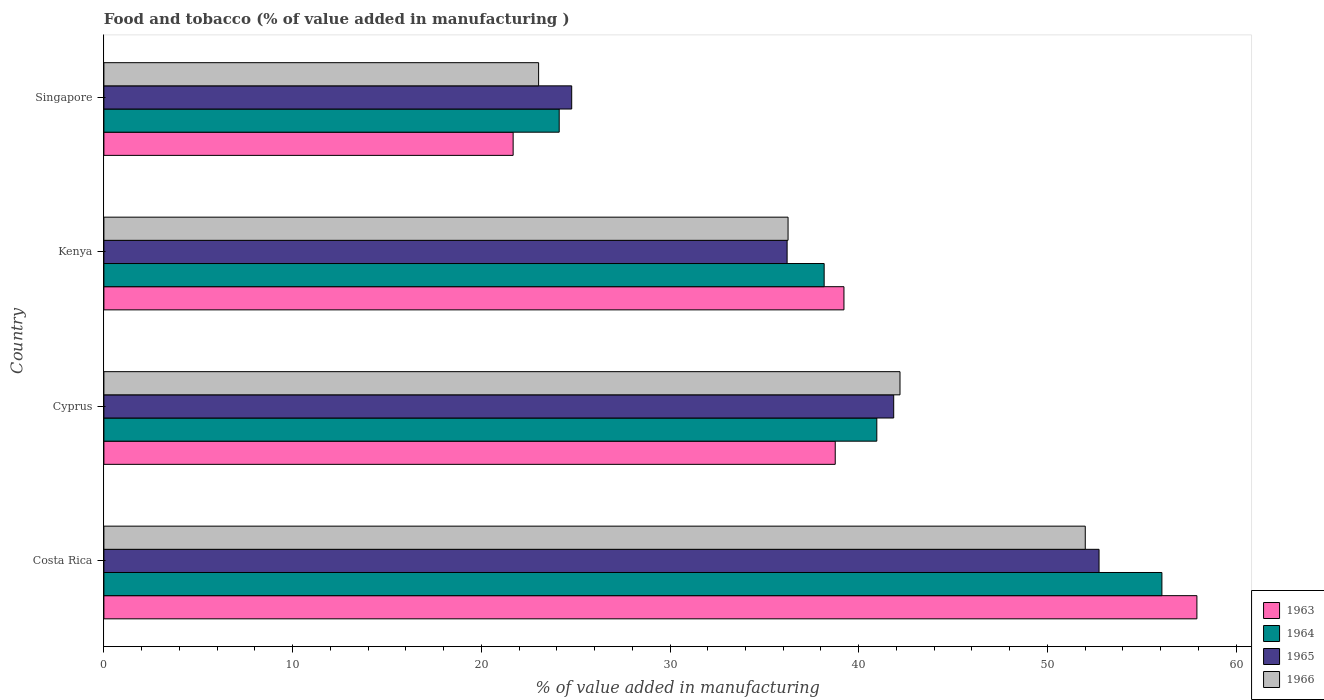How many different coloured bars are there?
Your answer should be compact. 4. How many groups of bars are there?
Provide a short and direct response. 4. How many bars are there on the 3rd tick from the bottom?
Offer a very short reply. 4. What is the label of the 1st group of bars from the top?
Keep it short and to the point. Singapore. In how many cases, is the number of bars for a given country not equal to the number of legend labels?
Offer a terse response. 0. What is the value added in manufacturing food and tobacco in 1966 in Cyprus?
Keep it short and to the point. 42.19. Across all countries, what is the maximum value added in manufacturing food and tobacco in 1965?
Keep it short and to the point. 52.73. Across all countries, what is the minimum value added in manufacturing food and tobacco in 1965?
Keep it short and to the point. 24.79. In which country was the value added in manufacturing food and tobacco in 1963 maximum?
Your response must be concise. Costa Rica. In which country was the value added in manufacturing food and tobacco in 1966 minimum?
Your answer should be very brief. Singapore. What is the total value added in manufacturing food and tobacco in 1965 in the graph?
Provide a short and direct response. 155.58. What is the difference between the value added in manufacturing food and tobacco in 1965 in Kenya and that in Singapore?
Keep it short and to the point. 11.41. What is the difference between the value added in manufacturing food and tobacco in 1964 in Costa Rica and the value added in manufacturing food and tobacco in 1966 in Singapore?
Offer a terse response. 33.03. What is the average value added in manufacturing food and tobacco in 1964 per country?
Your response must be concise. 39.83. What is the difference between the value added in manufacturing food and tobacco in 1966 and value added in manufacturing food and tobacco in 1965 in Costa Rica?
Keep it short and to the point. -0.73. What is the ratio of the value added in manufacturing food and tobacco in 1963 in Cyprus to that in Kenya?
Offer a terse response. 0.99. What is the difference between the highest and the second highest value added in manufacturing food and tobacco in 1965?
Provide a succinct answer. 10.88. What is the difference between the highest and the lowest value added in manufacturing food and tobacco in 1966?
Your answer should be compact. 28.97. In how many countries, is the value added in manufacturing food and tobacco in 1964 greater than the average value added in manufacturing food and tobacco in 1964 taken over all countries?
Offer a terse response. 2. What does the 1st bar from the top in Cyprus represents?
Ensure brevity in your answer.  1966. What does the 4th bar from the bottom in Kenya represents?
Provide a succinct answer. 1966. Is it the case that in every country, the sum of the value added in manufacturing food and tobacco in 1963 and value added in manufacturing food and tobacco in 1966 is greater than the value added in manufacturing food and tobacco in 1964?
Your answer should be very brief. Yes. How many countries are there in the graph?
Ensure brevity in your answer.  4. Are the values on the major ticks of X-axis written in scientific E-notation?
Make the answer very short. No. Does the graph contain any zero values?
Offer a very short reply. No. Does the graph contain grids?
Offer a very short reply. No. How many legend labels are there?
Provide a succinct answer. 4. How are the legend labels stacked?
Your response must be concise. Vertical. What is the title of the graph?
Make the answer very short. Food and tobacco (% of value added in manufacturing ). Does "2001" appear as one of the legend labels in the graph?
Provide a succinct answer. No. What is the label or title of the X-axis?
Ensure brevity in your answer.  % of value added in manufacturing. What is the label or title of the Y-axis?
Make the answer very short. Country. What is the % of value added in manufacturing in 1963 in Costa Rica?
Your answer should be compact. 57.92. What is the % of value added in manufacturing of 1964 in Costa Rica?
Keep it short and to the point. 56.07. What is the % of value added in manufacturing in 1965 in Costa Rica?
Give a very brief answer. 52.73. What is the % of value added in manufacturing of 1966 in Costa Rica?
Keep it short and to the point. 52. What is the % of value added in manufacturing in 1963 in Cyprus?
Make the answer very short. 38.75. What is the % of value added in manufacturing of 1964 in Cyprus?
Keep it short and to the point. 40.96. What is the % of value added in manufacturing in 1965 in Cyprus?
Your response must be concise. 41.85. What is the % of value added in manufacturing in 1966 in Cyprus?
Give a very brief answer. 42.19. What is the % of value added in manufacturing of 1963 in Kenya?
Offer a terse response. 39.22. What is the % of value added in manufacturing in 1964 in Kenya?
Provide a succinct answer. 38.17. What is the % of value added in manufacturing in 1965 in Kenya?
Keep it short and to the point. 36.2. What is the % of value added in manufacturing in 1966 in Kenya?
Your response must be concise. 36.25. What is the % of value added in manufacturing of 1963 in Singapore?
Ensure brevity in your answer.  21.69. What is the % of value added in manufacturing in 1964 in Singapore?
Offer a very short reply. 24.13. What is the % of value added in manufacturing in 1965 in Singapore?
Provide a short and direct response. 24.79. What is the % of value added in manufacturing in 1966 in Singapore?
Offer a terse response. 23.04. Across all countries, what is the maximum % of value added in manufacturing of 1963?
Keep it short and to the point. 57.92. Across all countries, what is the maximum % of value added in manufacturing of 1964?
Keep it short and to the point. 56.07. Across all countries, what is the maximum % of value added in manufacturing in 1965?
Provide a succinct answer. 52.73. Across all countries, what is the maximum % of value added in manufacturing of 1966?
Your response must be concise. 52. Across all countries, what is the minimum % of value added in manufacturing of 1963?
Provide a succinct answer. 21.69. Across all countries, what is the minimum % of value added in manufacturing in 1964?
Your answer should be very brief. 24.13. Across all countries, what is the minimum % of value added in manufacturing in 1965?
Provide a short and direct response. 24.79. Across all countries, what is the minimum % of value added in manufacturing of 1966?
Give a very brief answer. 23.04. What is the total % of value added in manufacturing of 1963 in the graph?
Provide a short and direct response. 157.58. What is the total % of value added in manufacturing in 1964 in the graph?
Offer a very short reply. 159.32. What is the total % of value added in manufacturing in 1965 in the graph?
Offer a very short reply. 155.58. What is the total % of value added in manufacturing in 1966 in the graph?
Keep it short and to the point. 153.48. What is the difference between the % of value added in manufacturing of 1963 in Costa Rica and that in Cyprus?
Offer a very short reply. 19.17. What is the difference between the % of value added in manufacturing in 1964 in Costa Rica and that in Cyprus?
Provide a short and direct response. 15.11. What is the difference between the % of value added in manufacturing in 1965 in Costa Rica and that in Cyprus?
Your response must be concise. 10.88. What is the difference between the % of value added in manufacturing in 1966 in Costa Rica and that in Cyprus?
Provide a succinct answer. 9.82. What is the difference between the % of value added in manufacturing in 1963 in Costa Rica and that in Kenya?
Your answer should be very brief. 18.7. What is the difference between the % of value added in manufacturing in 1964 in Costa Rica and that in Kenya?
Make the answer very short. 17.9. What is the difference between the % of value added in manufacturing in 1965 in Costa Rica and that in Kenya?
Offer a terse response. 16.53. What is the difference between the % of value added in manufacturing in 1966 in Costa Rica and that in Kenya?
Offer a terse response. 15.75. What is the difference between the % of value added in manufacturing in 1963 in Costa Rica and that in Singapore?
Provide a short and direct response. 36.23. What is the difference between the % of value added in manufacturing in 1964 in Costa Rica and that in Singapore?
Give a very brief answer. 31.94. What is the difference between the % of value added in manufacturing of 1965 in Costa Rica and that in Singapore?
Keep it short and to the point. 27.94. What is the difference between the % of value added in manufacturing of 1966 in Costa Rica and that in Singapore?
Your response must be concise. 28.97. What is the difference between the % of value added in manufacturing of 1963 in Cyprus and that in Kenya?
Give a very brief answer. -0.46. What is the difference between the % of value added in manufacturing in 1964 in Cyprus and that in Kenya?
Your response must be concise. 2.79. What is the difference between the % of value added in manufacturing of 1965 in Cyprus and that in Kenya?
Ensure brevity in your answer.  5.65. What is the difference between the % of value added in manufacturing of 1966 in Cyprus and that in Kenya?
Your response must be concise. 5.93. What is the difference between the % of value added in manufacturing of 1963 in Cyprus and that in Singapore?
Offer a terse response. 17.07. What is the difference between the % of value added in manufacturing in 1964 in Cyprus and that in Singapore?
Offer a very short reply. 16.83. What is the difference between the % of value added in manufacturing of 1965 in Cyprus and that in Singapore?
Give a very brief answer. 17.06. What is the difference between the % of value added in manufacturing in 1966 in Cyprus and that in Singapore?
Offer a very short reply. 19.15. What is the difference between the % of value added in manufacturing in 1963 in Kenya and that in Singapore?
Your answer should be compact. 17.53. What is the difference between the % of value added in manufacturing of 1964 in Kenya and that in Singapore?
Keep it short and to the point. 14.04. What is the difference between the % of value added in manufacturing in 1965 in Kenya and that in Singapore?
Your answer should be compact. 11.41. What is the difference between the % of value added in manufacturing of 1966 in Kenya and that in Singapore?
Provide a succinct answer. 13.22. What is the difference between the % of value added in manufacturing in 1963 in Costa Rica and the % of value added in manufacturing in 1964 in Cyprus?
Offer a very short reply. 16.96. What is the difference between the % of value added in manufacturing in 1963 in Costa Rica and the % of value added in manufacturing in 1965 in Cyprus?
Ensure brevity in your answer.  16.07. What is the difference between the % of value added in manufacturing in 1963 in Costa Rica and the % of value added in manufacturing in 1966 in Cyprus?
Provide a succinct answer. 15.73. What is the difference between the % of value added in manufacturing of 1964 in Costa Rica and the % of value added in manufacturing of 1965 in Cyprus?
Provide a succinct answer. 14.21. What is the difference between the % of value added in manufacturing in 1964 in Costa Rica and the % of value added in manufacturing in 1966 in Cyprus?
Give a very brief answer. 13.88. What is the difference between the % of value added in manufacturing in 1965 in Costa Rica and the % of value added in manufacturing in 1966 in Cyprus?
Keep it short and to the point. 10.55. What is the difference between the % of value added in manufacturing in 1963 in Costa Rica and the % of value added in manufacturing in 1964 in Kenya?
Offer a terse response. 19.75. What is the difference between the % of value added in manufacturing of 1963 in Costa Rica and the % of value added in manufacturing of 1965 in Kenya?
Offer a very short reply. 21.72. What is the difference between the % of value added in manufacturing in 1963 in Costa Rica and the % of value added in manufacturing in 1966 in Kenya?
Your answer should be compact. 21.67. What is the difference between the % of value added in manufacturing of 1964 in Costa Rica and the % of value added in manufacturing of 1965 in Kenya?
Ensure brevity in your answer.  19.86. What is the difference between the % of value added in manufacturing of 1964 in Costa Rica and the % of value added in manufacturing of 1966 in Kenya?
Give a very brief answer. 19.81. What is the difference between the % of value added in manufacturing of 1965 in Costa Rica and the % of value added in manufacturing of 1966 in Kenya?
Offer a very short reply. 16.48. What is the difference between the % of value added in manufacturing of 1963 in Costa Rica and the % of value added in manufacturing of 1964 in Singapore?
Provide a short and direct response. 33.79. What is the difference between the % of value added in manufacturing of 1963 in Costa Rica and the % of value added in manufacturing of 1965 in Singapore?
Your answer should be compact. 33.13. What is the difference between the % of value added in manufacturing of 1963 in Costa Rica and the % of value added in manufacturing of 1966 in Singapore?
Provide a short and direct response. 34.88. What is the difference between the % of value added in manufacturing in 1964 in Costa Rica and the % of value added in manufacturing in 1965 in Singapore?
Your answer should be compact. 31.28. What is the difference between the % of value added in manufacturing in 1964 in Costa Rica and the % of value added in manufacturing in 1966 in Singapore?
Ensure brevity in your answer.  33.03. What is the difference between the % of value added in manufacturing of 1965 in Costa Rica and the % of value added in manufacturing of 1966 in Singapore?
Offer a very short reply. 29.7. What is the difference between the % of value added in manufacturing in 1963 in Cyprus and the % of value added in manufacturing in 1964 in Kenya?
Ensure brevity in your answer.  0.59. What is the difference between the % of value added in manufacturing of 1963 in Cyprus and the % of value added in manufacturing of 1965 in Kenya?
Keep it short and to the point. 2.55. What is the difference between the % of value added in manufacturing in 1963 in Cyprus and the % of value added in manufacturing in 1966 in Kenya?
Make the answer very short. 2.5. What is the difference between the % of value added in manufacturing of 1964 in Cyprus and the % of value added in manufacturing of 1965 in Kenya?
Ensure brevity in your answer.  4.75. What is the difference between the % of value added in manufacturing in 1964 in Cyprus and the % of value added in manufacturing in 1966 in Kenya?
Give a very brief answer. 4.7. What is the difference between the % of value added in manufacturing in 1965 in Cyprus and the % of value added in manufacturing in 1966 in Kenya?
Offer a terse response. 5.6. What is the difference between the % of value added in manufacturing of 1963 in Cyprus and the % of value added in manufacturing of 1964 in Singapore?
Give a very brief answer. 14.63. What is the difference between the % of value added in manufacturing of 1963 in Cyprus and the % of value added in manufacturing of 1965 in Singapore?
Ensure brevity in your answer.  13.96. What is the difference between the % of value added in manufacturing of 1963 in Cyprus and the % of value added in manufacturing of 1966 in Singapore?
Your response must be concise. 15.72. What is the difference between the % of value added in manufacturing of 1964 in Cyprus and the % of value added in manufacturing of 1965 in Singapore?
Your answer should be compact. 16.17. What is the difference between the % of value added in manufacturing of 1964 in Cyprus and the % of value added in manufacturing of 1966 in Singapore?
Make the answer very short. 17.92. What is the difference between the % of value added in manufacturing of 1965 in Cyprus and the % of value added in manufacturing of 1966 in Singapore?
Offer a very short reply. 18.82. What is the difference between the % of value added in manufacturing of 1963 in Kenya and the % of value added in manufacturing of 1964 in Singapore?
Your response must be concise. 15.09. What is the difference between the % of value added in manufacturing of 1963 in Kenya and the % of value added in manufacturing of 1965 in Singapore?
Make the answer very short. 14.43. What is the difference between the % of value added in manufacturing in 1963 in Kenya and the % of value added in manufacturing in 1966 in Singapore?
Your response must be concise. 16.18. What is the difference between the % of value added in manufacturing of 1964 in Kenya and the % of value added in manufacturing of 1965 in Singapore?
Make the answer very short. 13.38. What is the difference between the % of value added in manufacturing of 1964 in Kenya and the % of value added in manufacturing of 1966 in Singapore?
Offer a very short reply. 15.13. What is the difference between the % of value added in manufacturing in 1965 in Kenya and the % of value added in manufacturing in 1966 in Singapore?
Offer a terse response. 13.17. What is the average % of value added in manufacturing of 1963 per country?
Provide a succinct answer. 39.39. What is the average % of value added in manufacturing of 1964 per country?
Give a very brief answer. 39.83. What is the average % of value added in manufacturing of 1965 per country?
Your answer should be compact. 38.9. What is the average % of value added in manufacturing of 1966 per country?
Keep it short and to the point. 38.37. What is the difference between the % of value added in manufacturing of 1963 and % of value added in manufacturing of 1964 in Costa Rica?
Make the answer very short. 1.85. What is the difference between the % of value added in manufacturing of 1963 and % of value added in manufacturing of 1965 in Costa Rica?
Provide a short and direct response. 5.19. What is the difference between the % of value added in manufacturing of 1963 and % of value added in manufacturing of 1966 in Costa Rica?
Your answer should be compact. 5.92. What is the difference between the % of value added in manufacturing in 1964 and % of value added in manufacturing in 1965 in Costa Rica?
Make the answer very short. 3.33. What is the difference between the % of value added in manufacturing of 1964 and % of value added in manufacturing of 1966 in Costa Rica?
Offer a very short reply. 4.06. What is the difference between the % of value added in manufacturing in 1965 and % of value added in manufacturing in 1966 in Costa Rica?
Offer a very short reply. 0.73. What is the difference between the % of value added in manufacturing of 1963 and % of value added in manufacturing of 1964 in Cyprus?
Make the answer very short. -2.2. What is the difference between the % of value added in manufacturing of 1963 and % of value added in manufacturing of 1965 in Cyprus?
Your response must be concise. -3.1. What is the difference between the % of value added in manufacturing of 1963 and % of value added in manufacturing of 1966 in Cyprus?
Offer a very short reply. -3.43. What is the difference between the % of value added in manufacturing of 1964 and % of value added in manufacturing of 1965 in Cyprus?
Keep it short and to the point. -0.9. What is the difference between the % of value added in manufacturing of 1964 and % of value added in manufacturing of 1966 in Cyprus?
Make the answer very short. -1.23. What is the difference between the % of value added in manufacturing of 1965 and % of value added in manufacturing of 1966 in Cyprus?
Your answer should be very brief. -0.33. What is the difference between the % of value added in manufacturing in 1963 and % of value added in manufacturing in 1964 in Kenya?
Your response must be concise. 1.05. What is the difference between the % of value added in manufacturing in 1963 and % of value added in manufacturing in 1965 in Kenya?
Your answer should be very brief. 3.01. What is the difference between the % of value added in manufacturing of 1963 and % of value added in manufacturing of 1966 in Kenya?
Your answer should be compact. 2.96. What is the difference between the % of value added in manufacturing in 1964 and % of value added in manufacturing in 1965 in Kenya?
Keep it short and to the point. 1.96. What is the difference between the % of value added in manufacturing in 1964 and % of value added in manufacturing in 1966 in Kenya?
Keep it short and to the point. 1.91. What is the difference between the % of value added in manufacturing in 1965 and % of value added in manufacturing in 1966 in Kenya?
Provide a succinct answer. -0.05. What is the difference between the % of value added in manufacturing in 1963 and % of value added in manufacturing in 1964 in Singapore?
Offer a terse response. -2.44. What is the difference between the % of value added in manufacturing in 1963 and % of value added in manufacturing in 1965 in Singapore?
Keep it short and to the point. -3.1. What is the difference between the % of value added in manufacturing in 1963 and % of value added in manufacturing in 1966 in Singapore?
Your answer should be very brief. -1.35. What is the difference between the % of value added in manufacturing in 1964 and % of value added in manufacturing in 1965 in Singapore?
Keep it short and to the point. -0.66. What is the difference between the % of value added in manufacturing of 1964 and % of value added in manufacturing of 1966 in Singapore?
Your answer should be compact. 1.09. What is the difference between the % of value added in manufacturing of 1965 and % of value added in manufacturing of 1966 in Singapore?
Keep it short and to the point. 1.75. What is the ratio of the % of value added in manufacturing in 1963 in Costa Rica to that in Cyprus?
Your answer should be very brief. 1.49. What is the ratio of the % of value added in manufacturing of 1964 in Costa Rica to that in Cyprus?
Your answer should be compact. 1.37. What is the ratio of the % of value added in manufacturing in 1965 in Costa Rica to that in Cyprus?
Your response must be concise. 1.26. What is the ratio of the % of value added in manufacturing in 1966 in Costa Rica to that in Cyprus?
Provide a succinct answer. 1.23. What is the ratio of the % of value added in manufacturing in 1963 in Costa Rica to that in Kenya?
Provide a succinct answer. 1.48. What is the ratio of the % of value added in manufacturing of 1964 in Costa Rica to that in Kenya?
Offer a terse response. 1.47. What is the ratio of the % of value added in manufacturing of 1965 in Costa Rica to that in Kenya?
Offer a terse response. 1.46. What is the ratio of the % of value added in manufacturing of 1966 in Costa Rica to that in Kenya?
Your response must be concise. 1.43. What is the ratio of the % of value added in manufacturing in 1963 in Costa Rica to that in Singapore?
Give a very brief answer. 2.67. What is the ratio of the % of value added in manufacturing of 1964 in Costa Rica to that in Singapore?
Offer a very short reply. 2.32. What is the ratio of the % of value added in manufacturing of 1965 in Costa Rica to that in Singapore?
Provide a succinct answer. 2.13. What is the ratio of the % of value added in manufacturing of 1966 in Costa Rica to that in Singapore?
Your response must be concise. 2.26. What is the ratio of the % of value added in manufacturing of 1964 in Cyprus to that in Kenya?
Offer a very short reply. 1.07. What is the ratio of the % of value added in manufacturing of 1965 in Cyprus to that in Kenya?
Ensure brevity in your answer.  1.16. What is the ratio of the % of value added in manufacturing of 1966 in Cyprus to that in Kenya?
Your answer should be very brief. 1.16. What is the ratio of the % of value added in manufacturing of 1963 in Cyprus to that in Singapore?
Your answer should be very brief. 1.79. What is the ratio of the % of value added in manufacturing of 1964 in Cyprus to that in Singapore?
Offer a very short reply. 1.7. What is the ratio of the % of value added in manufacturing in 1965 in Cyprus to that in Singapore?
Your response must be concise. 1.69. What is the ratio of the % of value added in manufacturing of 1966 in Cyprus to that in Singapore?
Ensure brevity in your answer.  1.83. What is the ratio of the % of value added in manufacturing in 1963 in Kenya to that in Singapore?
Your response must be concise. 1.81. What is the ratio of the % of value added in manufacturing of 1964 in Kenya to that in Singapore?
Your answer should be very brief. 1.58. What is the ratio of the % of value added in manufacturing of 1965 in Kenya to that in Singapore?
Your answer should be compact. 1.46. What is the ratio of the % of value added in manufacturing in 1966 in Kenya to that in Singapore?
Keep it short and to the point. 1.57. What is the difference between the highest and the second highest % of value added in manufacturing in 1963?
Your answer should be very brief. 18.7. What is the difference between the highest and the second highest % of value added in manufacturing of 1964?
Your response must be concise. 15.11. What is the difference between the highest and the second highest % of value added in manufacturing of 1965?
Ensure brevity in your answer.  10.88. What is the difference between the highest and the second highest % of value added in manufacturing of 1966?
Give a very brief answer. 9.82. What is the difference between the highest and the lowest % of value added in manufacturing in 1963?
Keep it short and to the point. 36.23. What is the difference between the highest and the lowest % of value added in manufacturing in 1964?
Ensure brevity in your answer.  31.94. What is the difference between the highest and the lowest % of value added in manufacturing in 1965?
Your answer should be compact. 27.94. What is the difference between the highest and the lowest % of value added in manufacturing of 1966?
Provide a short and direct response. 28.97. 